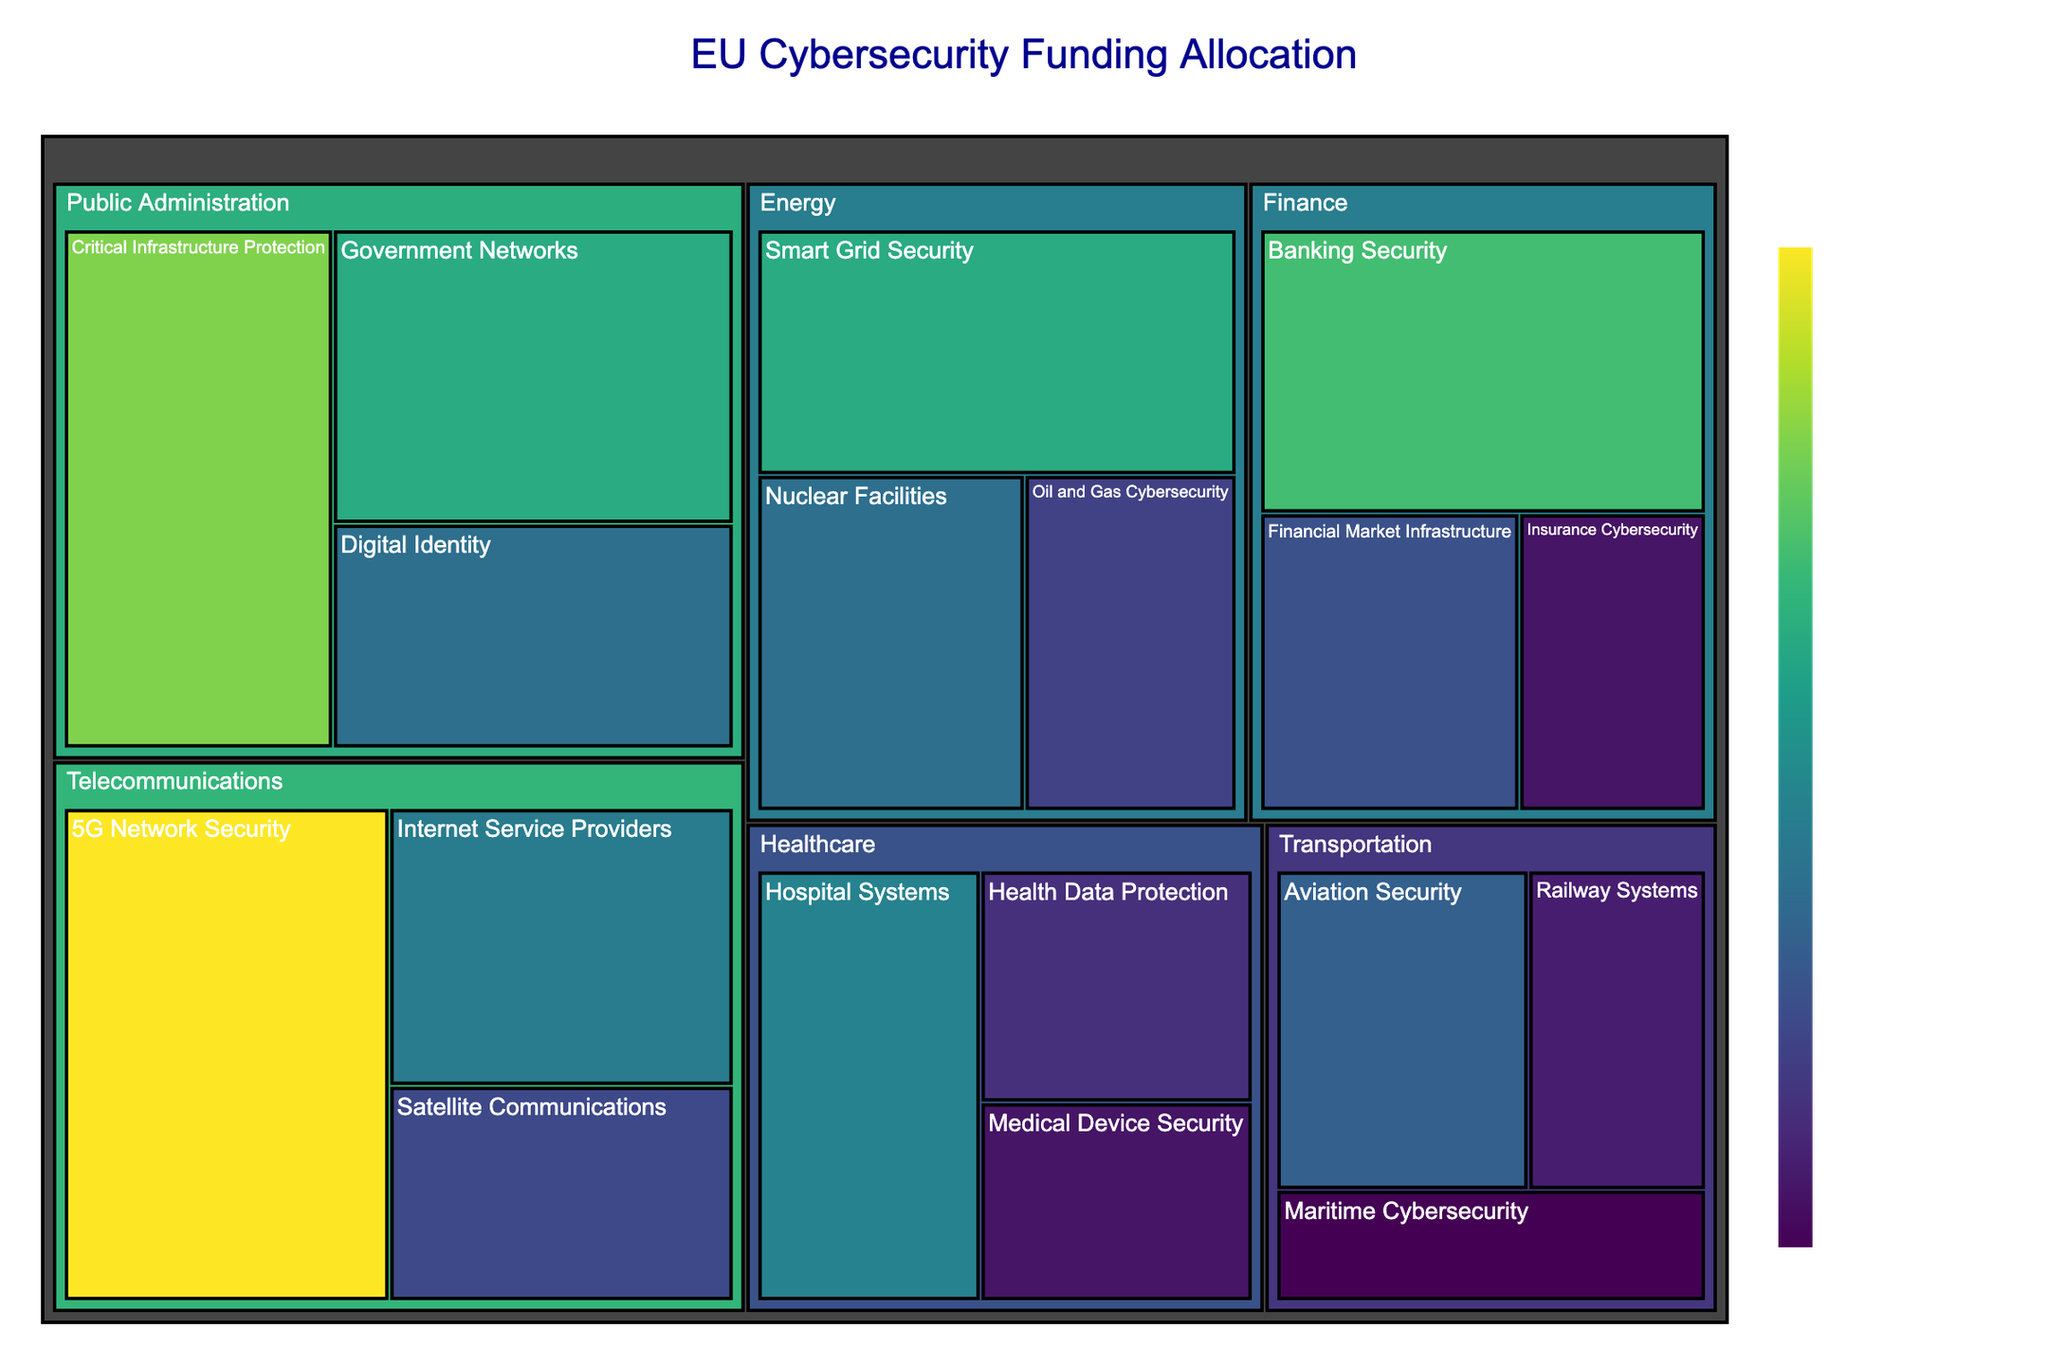What is the title of the treemap? The title of the treemap is prominently displayed at the top center of the figure. It gives the viewer an immediate understanding of what the visualization represents. The title can be found in a larger font size compared to other text in the treemap.
Answer: EU Cybersecurity Funding Allocation Which sector received the highest funding? The sector with the largest funding allocation can be identified by the size of its section in the treemap. The largest block within the treemap corresponds to the Telecommunications sector.
Answer: Telecommunications What is the total funding allocated for Public Administration? To find the total funding for Public Administration, sum the values for each of its subsectors: Critical Infrastructure Protection (€450M), Government Networks (€380M), and Digital Identity (€290M). So, 450 + 380 + 290 = 1120M EUR.
Answer: 1120M EUR How does the funding for 5G Network Security compare to Smart Grid Security? To compare the funding for these two subsectors, locate their respective blocks in the treemap. The amount for 5G Network Security (€520M) is larger than that for Smart Grid Security (€380M).
Answer: 5G Network Security received more funding What is the smallest subsector in terms of funding within the Transportation sector? To find the smallest subsector, compare the funding amounts within the Transportation sector. Maritime Cybersecurity has the smallest allocation with €160M.
Answer: Maritime Cybersecurity Which subsector in the Finance sector received the highest funding? Within the Finance sector, compare the three subsectors by their funding amounts. Banking Security has the highest allocation at €410M.
Answer: Banking Security What is the combined funding for the Healthcare and Energy sectors? Sum the total funding for all subsectors within Healthcare (Hospital Systems: €320M, Medical Device Security: €180M, Health Data Protection: €210M) and Energy (Smart Grid Security: €380M, Nuclear Facilities: €290M, Oil and Gas Cybersecurity: €230M). So, (320 + 180 + 210) + (380 + 290 + 230) = 1010M EUR.
Answer: 1010M EUR If we combine the funding for Digital Identity and Internet Service Providers, how does it compare to Aviation Security? Total funding for Digital Identity and Internet Service Providers is 290 (Digital Identity) + 310 (Internet Service Providers) = 600M EUR. Compare this with Aviation Security's 270M EUR. The combined funding is higher.
Answer: Combined funding is higher What is the funding difference between Government Networks and Satellite Communications? Subtract the funding for Satellite Communications (€240M) from Government Networks (€380M). So, 380 - 240 = 140M EUR.
Answer: 140M EUR Which subsector has more funding: Nuclear Facilities or Financial Market Infrastructure? Compare the funding for these subsectors. Nuclear Facilities received €290M, while Financial Market Infrastructure received €250M.
Answer: Nuclear Facilities 